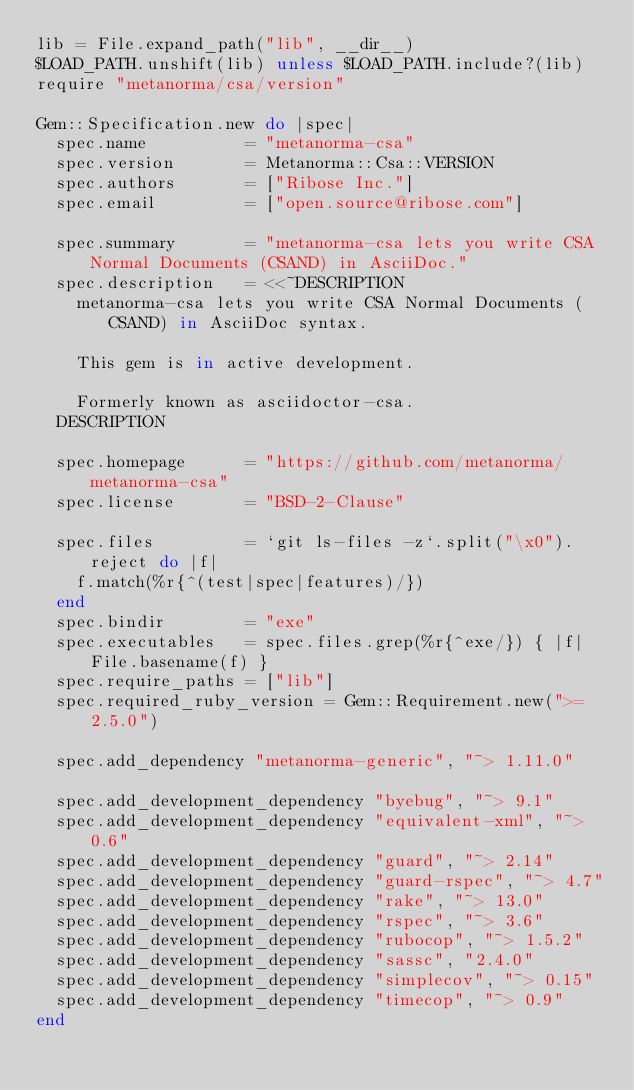<code> <loc_0><loc_0><loc_500><loc_500><_Ruby_>lib = File.expand_path("lib", __dir__)
$LOAD_PATH.unshift(lib) unless $LOAD_PATH.include?(lib)
require "metanorma/csa/version"

Gem::Specification.new do |spec|
  spec.name          = "metanorma-csa"
  spec.version       = Metanorma::Csa::VERSION
  spec.authors       = ["Ribose Inc."]
  spec.email         = ["open.source@ribose.com"]

  spec.summary       = "metanorma-csa lets you write CSA Normal Documents (CSAND) in AsciiDoc."
  spec.description   = <<~DESCRIPTION
    metanorma-csa lets you write CSA Normal Documents (CSAND) in AsciiDoc syntax.

    This gem is in active development.

    Formerly known as asciidoctor-csa.
  DESCRIPTION

  spec.homepage      = "https://github.com/metanorma/metanorma-csa"
  spec.license       = "BSD-2-Clause"

  spec.files         = `git ls-files -z`.split("\x0").reject do |f|
    f.match(%r{^(test|spec|features)/})
  end
  spec.bindir        = "exe"
  spec.executables   = spec.files.grep(%r{^exe/}) { |f| File.basename(f) }
  spec.require_paths = ["lib"]
  spec.required_ruby_version = Gem::Requirement.new(">= 2.5.0")

  spec.add_dependency "metanorma-generic", "~> 1.11.0"

  spec.add_development_dependency "byebug", "~> 9.1"
  spec.add_development_dependency "equivalent-xml", "~> 0.6"
  spec.add_development_dependency "guard", "~> 2.14"
  spec.add_development_dependency "guard-rspec", "~> 4.7"
  spec.add_development_dependency "rake", "~> 13.0"
  spec.add_development_dependency "rspec", "~> 3.6"
  spec.add_development_dependency "rubocop", "~> 1.5.2"
  spec.add_development_dependency "sassc", "2.4.0"
  spec.add_development_dependency "simplecov", "~> 0.15"
  spec.add_development_dependency "timecop", "~> 0.9"
end
</code> 